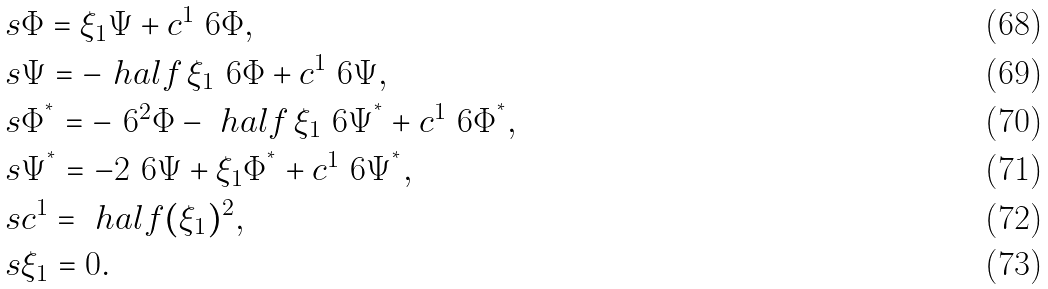Convert formula to latex. <formula><loc_0><loc_0><loc_500><loc_500>& s \Phi = \xi _ { 1 } \Psi + c ^ { 1 } \ 6 \Phi , \\ & s \Psi = - \ h a l f \, \xi _ { 1 } \ 6 \Phi + c ^ { 1 } \ 6 \Psi , \\ & s \Phi ^ { ^ { * } } = - \ 6 ^ { 2 } \Phi - \ h a l f \, \xi _ { 1 } \ 6 \Psi ^ { ^ { * } } + c ^ { 1 } \ 6 \Phi ^ { ^ { * } } , \\ & s \Psi ^ { ^ { * } } = - 2 \ 6 \Psi + \xi _ { 1 } \Phi ^ { ^ { * } } + c ^ { 1 } \ 6 \Psi ^ { ^ { * } } , \\ & s c ^ { 1 } = \ h a l f ( \xi _ { 1 } ) ^ { 2 } , \\ & s \xi _ { 1 } = 0 .</formula> 